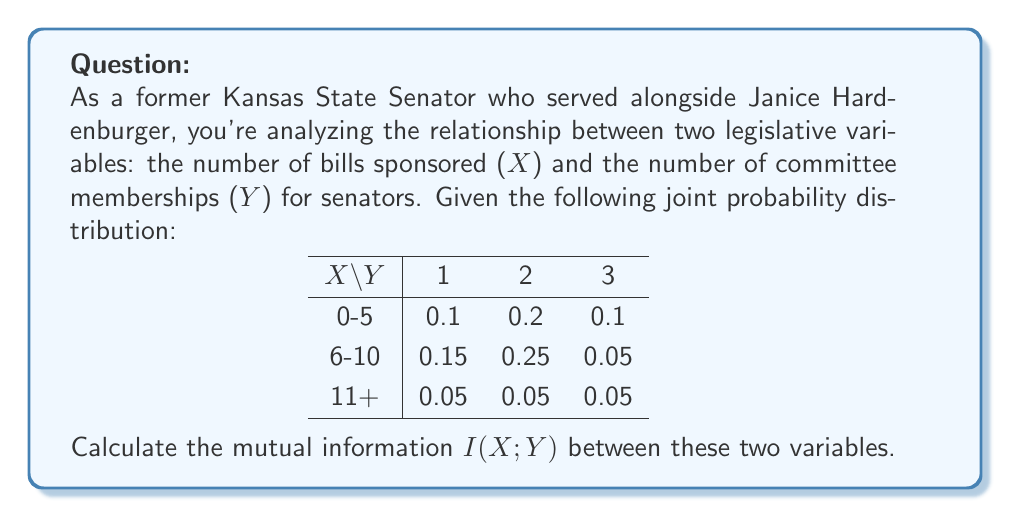Provide a solution to this math problem. To calculate the mutual information I(X;Y), we'll follow these steps:

1) First, we need to calculate the marginal probabilities for X and Y:

   P(X = 0-5) = 0.1 + 0.2 + 0.1 = 0.4
   P(X = 6-10) = 0.15 + 0.25 + 0.05 = 0.45
   P(X = 11+) = 0.05 + 0.05 + 0.05 = 0.15

   P(Y = 1) = 0.1 + 0.15 + 0.05 = 0.3
   P(Y = 2) = 0.2 + 0.25 + 0.05 = 0.5
   P(Y = 3) = 0.1 + 0.05 + 0.05 = 0.2

2) The formula for mutual information is:

   $$I(X;Y) = \sum_{x}\sum_{y} P(x,y) \log_2 \frac{P(x,y)}{P(x)P(y)}$$

3) Now, we calculate each term:

   0.1 * log2(0.1 / (0.4 * 0.3)) ≈ -0.0610
   0.2 * log2(0.2 / (0.4 * 0.5)) ≈ 0.0611
   0.1 * log2(0.1 / (0.4 * 0.2)) ≈ 0.0611
   0.15 * log2(0.15 / (0.45 * 0.3)) ≈ 0.0205
   0.25 * log2(0.25 / (0.45 * 0.5)) ≈ 0.0527
   0.05 * log2(0.05 / (0.45 * 0.2)) ≈ -0.0389
   0.05 * log2(0.05 / (0.15 * 0.3)) ≈ 0.0201
   0.05 * log2(0.05 / (0.15 * 0.5)) ≈ -0.0110
   0.05 * log2(0.05 / (0.15 * 0.2)) ≈ 0.0611

4) Sum all these terms:

   I(X;Y) ≈ 0.1657 bits
Answer: 0.1657 bits 